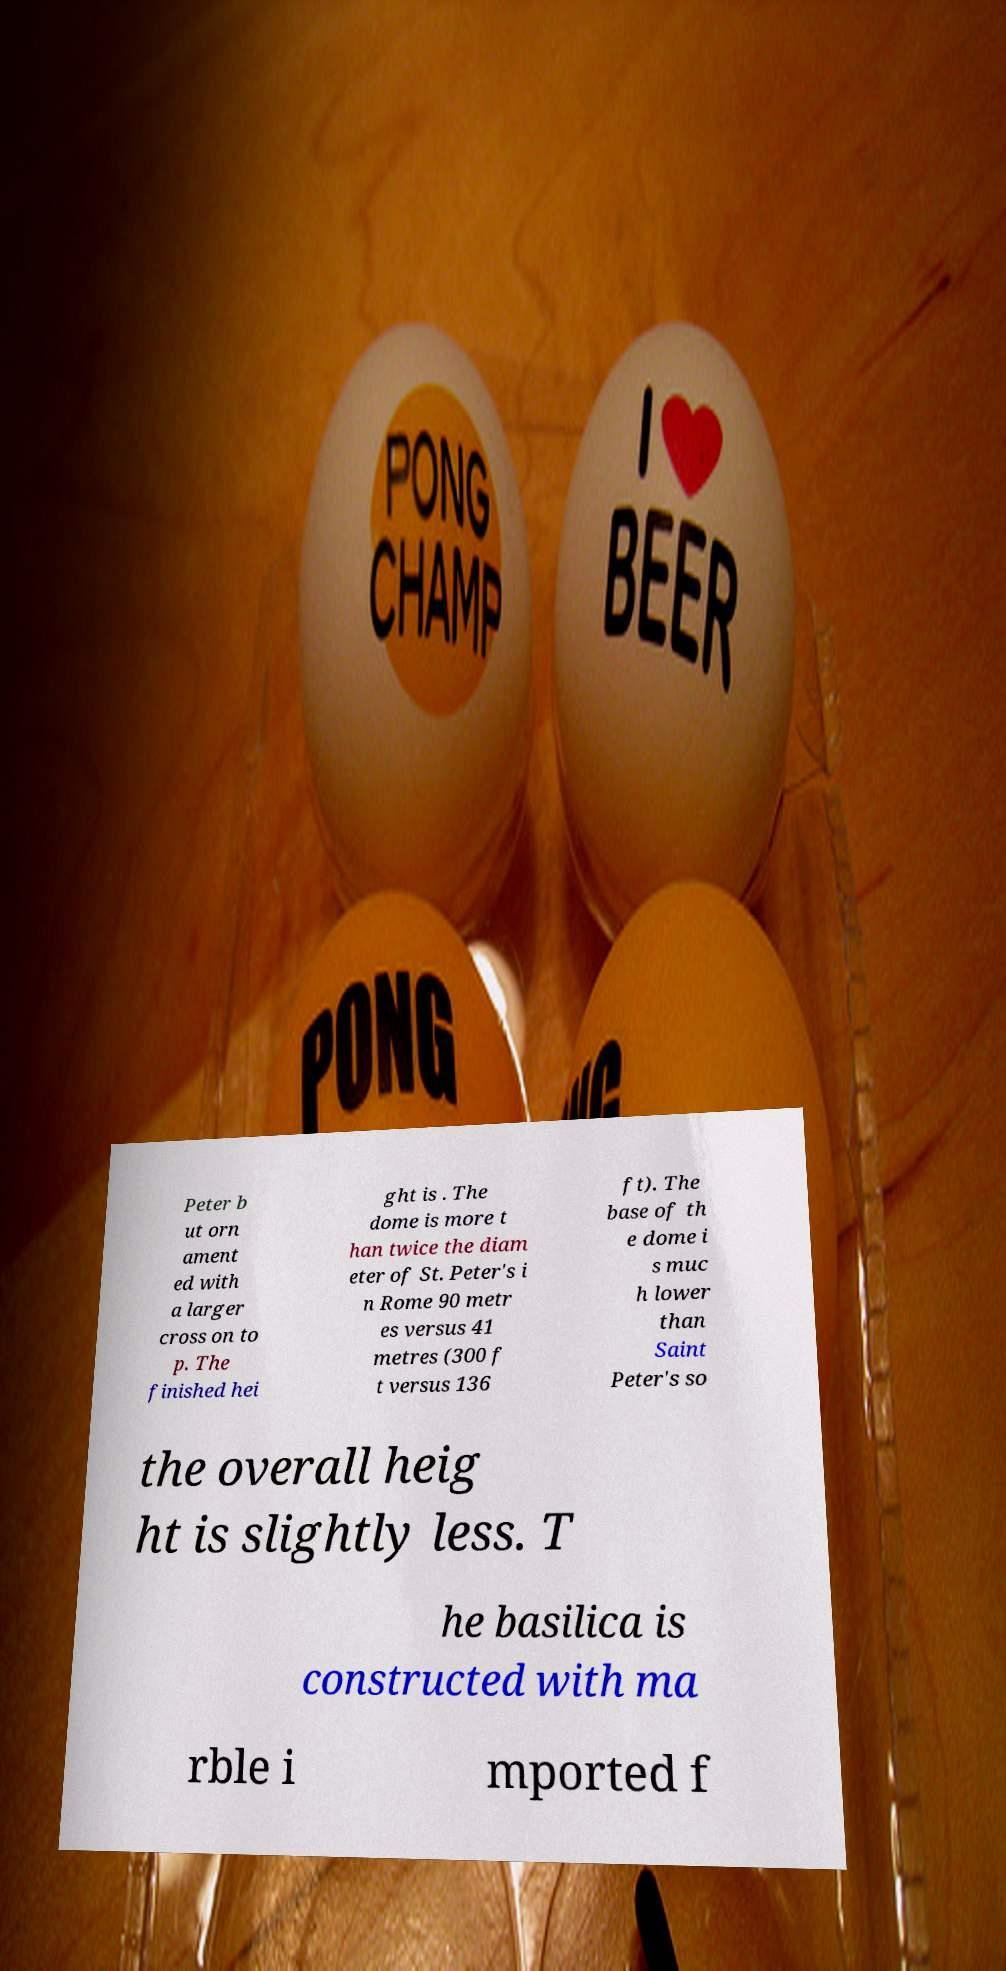There's text embedded in this image that I need extracted. Can you transcribe it verbatim? Peter b ut orn ament ed with a larger cross on to p. The finished hei ght is . The dome is more t han twice the diam eter of St. Peter's i n Rome 90 metr es versus 41 metres (300 f t versus 136 ft). The base of th e dome i s muc h lower than Saint Peter's so the overall heig ht is slightly less. T he basilica is constructed with ma rble i mported f 